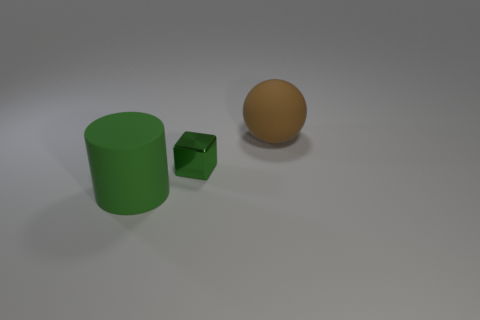What number of objects are right of the large object that is in front of the large rubber thing behind the metallic block?
Your answer should be very brief. 2. The green thing that is the same material as the large sphere is what size?
Make the answer very short. Large. How many rubber cylinders are the same color as the tiny object?
Your answer should be very brief. 1. There is a brown object that is on the right side of the green block; is its size the same as the tiny shiny block?
Give a very brief answer. No. There is a thing that is both in front of the big matte sphere and on the right side of the big cylinder; what color is it?
Keep it short and to the point. Green. How many objects are blocks or large rubber things to the left of the large brown sphere?
Keep it short and to the point. 2. What is the material of the large object in front of the matte object to the right of the matte thing that is to the left of the cube?
Provide a short and direct response. Rubber. Are there any other things that have the same material as the cube?
Provide a succinct answer. No. Do the big thing behind the cylinder and the small metal cube have the same color?
Provide a short and direct response. No. How many green things are metal things or small matte balls?
Ensure brevity in your answer.  1. 